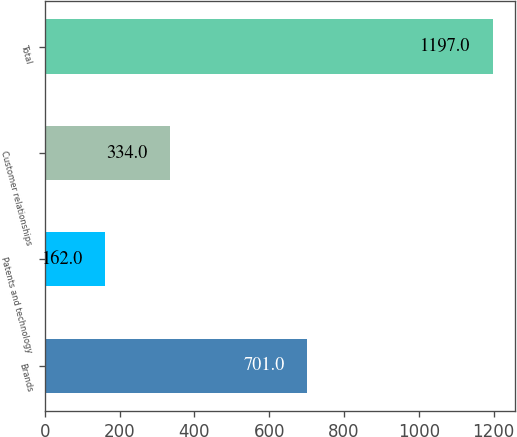Convert chart to OTSL. <chart><loc_0><loc_0><loc_500><loc_500><bar_chart><fcel>Brands<fcel>Patents and technology<fcel>Customer relationships<fcel>Total<nl><fcel>701<fcel>162<fcel>334<fcel>1197<nl></chart> 